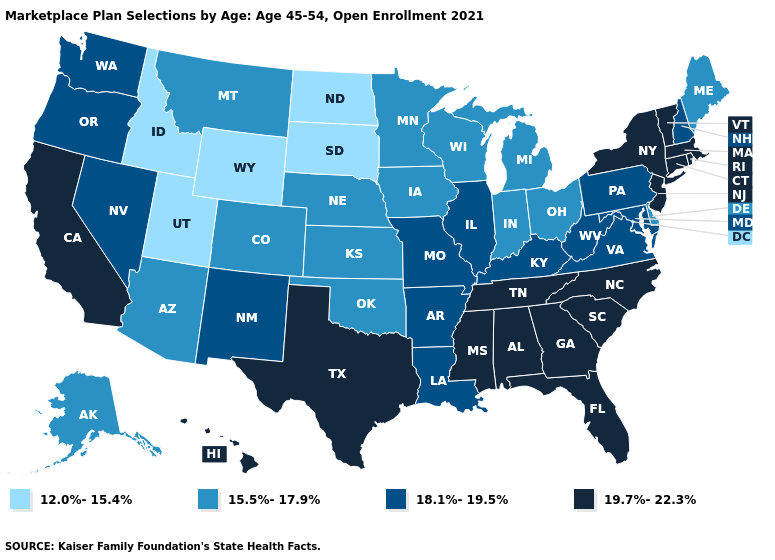Is the legend a continuous bar?
Answer briefly. No. What is the lowest value in the Northeast?
Be succinct. 15.5%-17.9%. Name the states that have a value in the range 12.0%-15.4%?
Be succinct. Idaho, North Dakota, South Dakota, Utah, Wyoming. Which states have the lowest value in the Northeast?
Write a very short answer. Maine. What is the value of Oklahoma?
Concise answer only. 15.5%-17.9%. Does Mississippi have the highest value in the South?
Give a very brief answer. Yes. Name the states that have a value in the range 19.7%-22.3%?
Short answer required. Alabama, California, Connecticut, Florida, Georgia, Hawaii, Massachusetts, Mississippi, New Jersey, New York, North Carolina, Rhode Island, South Carolina, Tennessee, Texas, Vermont. Among the states that border Maryland , which have the lowest value?
Keep it brief. Delaware. Does Utah have the highest value in the USA?
Short answer required. No. Name the states that have a value in the range 15.5%-17.9%?
Write a very short answer. Alaska, Arizona, Colorado, Delaware, Indiana, Iowa, Kansas, Maine, Michigan, Minnesota, Montana, Nebraska, Ohio, Oklahoma, Wisconsin. What is the value of Pennsylvania?
Short answer required. 18.1%-19.5%. What is the lowest value in the Northeast?
Concise answer only. 15.5%-17.9%. Does Kentucky have the highest value in the South?
Write a very short answer. No. 